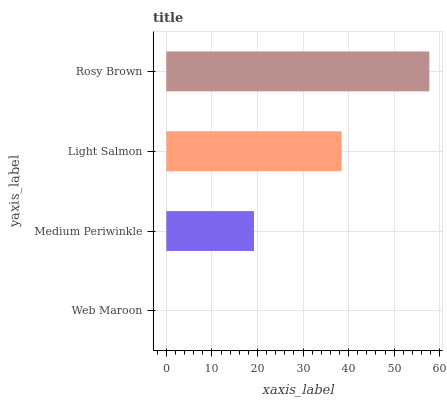Is Web Maroon the minimum?
Answer yes or no. Yes. Is Rosy Brown the maximum?
Answer yes or no. Yes. Is Medium Periwinkle the minimum?
Answer yes or no. No. Is Medium Periwinkle the maximum?
Answer yes or no. No. Is Medium Periwinkle greater than Web Maroon?
Answer yes or no. Yes. Is Web Maroon less than Medium Periwinkle?
Answer yes or no. Yes. Is Web Maroon greater than Medium Periwinkle?
Answer yes or no. No. Is Medium Periwinkle less than Web Maroon?
Answer yes or no. No. Is Light Salmon the high median?
Answer yes or no. Yes. Is Medium Periwinkle the low median?
Answer yes or no. Yes. Is Medium Periwinkle the high median?
Answer yes or no. No. Is Rosy Brown the low median?
Answer yes or no. No. 